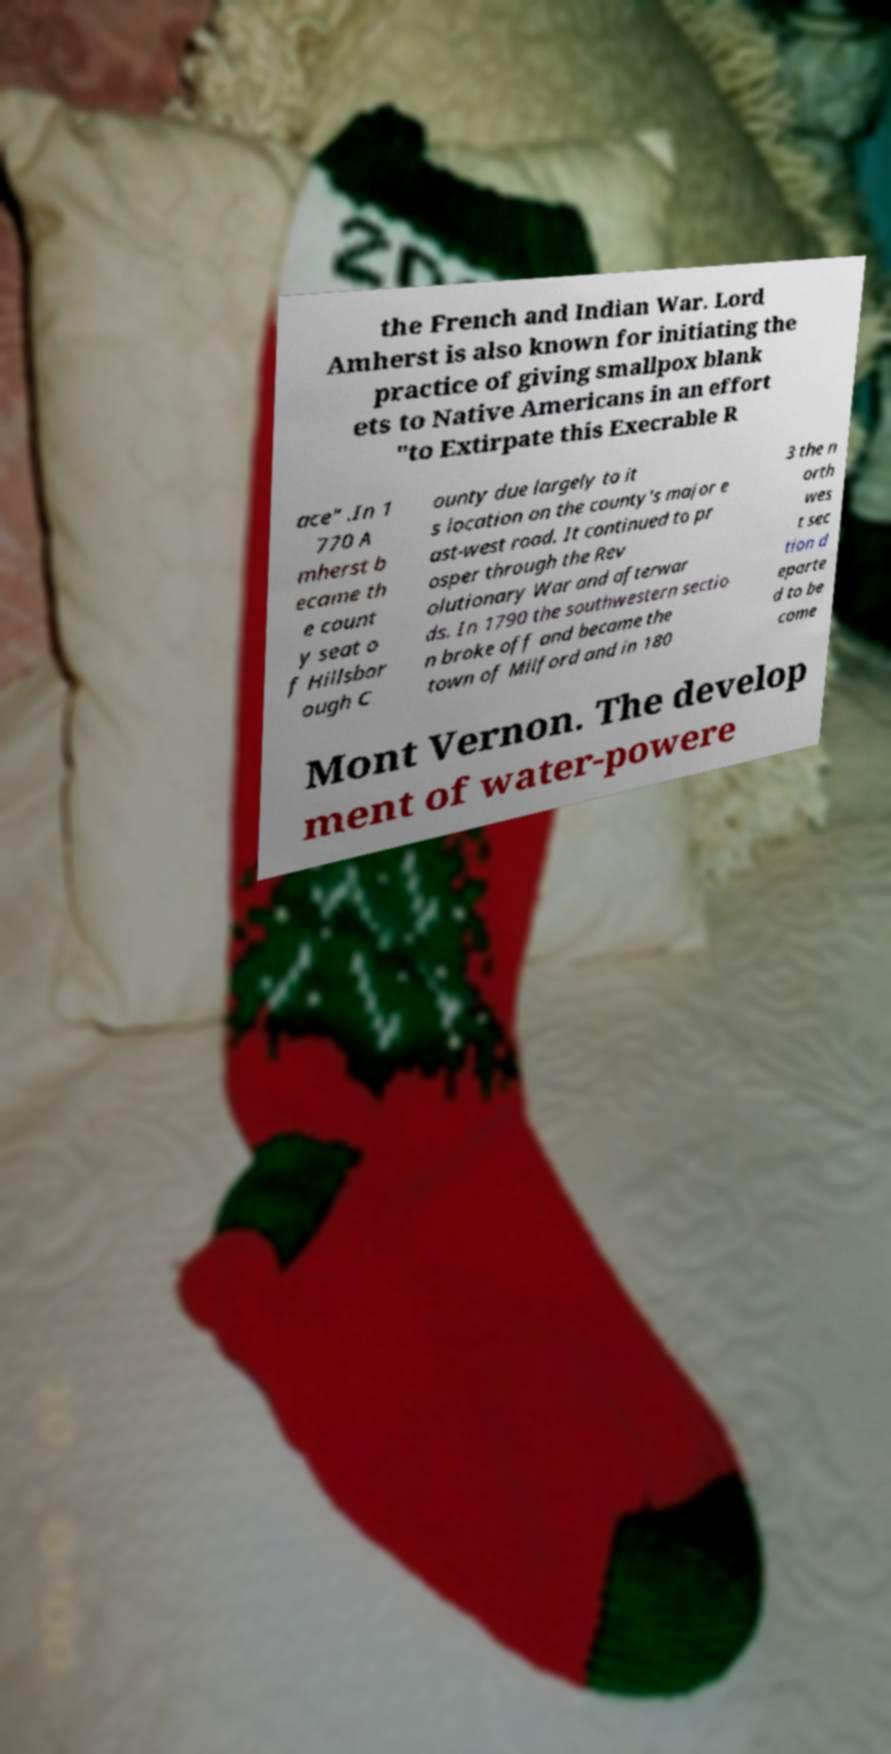What messages or text are displayed in this image? I need them in a readable, typed format. the French and Indian War. Lord Amherst is also known for initiating the practice of giving smallpox blank ets to Native Americans in an effort "to Extirpate this Execrable R ace" .In 1 770 A mherst b ecame th e count y seat o f Hillsbor ough C ounty due largely to it s location on the county's major e ast-west road. It continued to pr osper through the Rev olutionary War and afterwar ds. In 1790 the southwestern sectio n broke off and became the town of Milford and in 180 3 the n orth wes t sec tion d eparte d to be come Mont Vernon. The develop ment of water-powere 